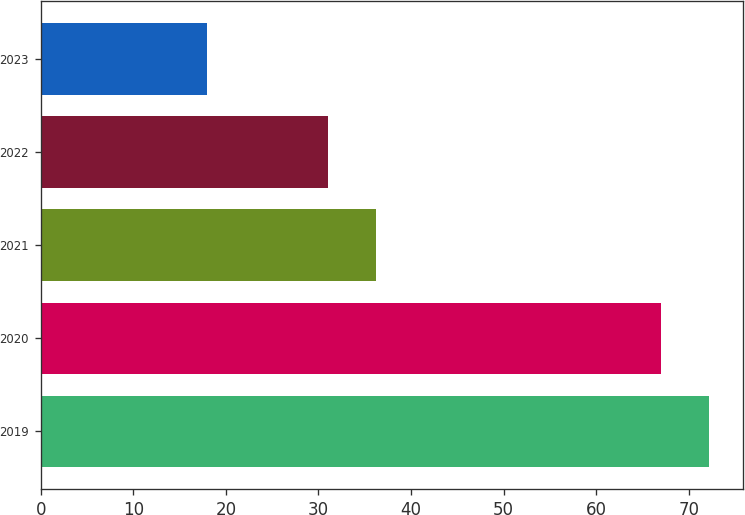Convert chart to OTSL. <chart><loc_0><loc_0><loc_500><loc_500><bar_chart><fcel>2019<fcel>2020<fcel>2021<fcel>2022<fcel>2023<nl><fcel>72.2<fcel>67<fcel>36.2<fcel>31<fcel>18<nl></chart> 